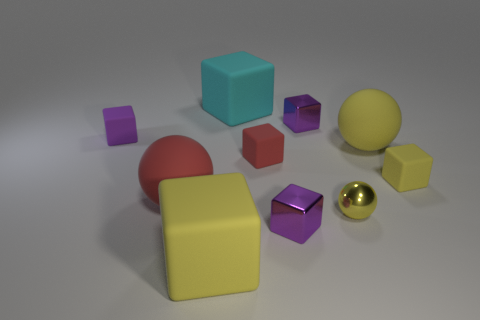How many other things are there of the same size as the yellow matte sphere?
Your response must be concise. 3. What material is the purple object in front of the large object on the right side of the purple thing that is in front of the tiny red matte block?
Offer a terse response. Metal. Is the material of the small red cube the same as the yellow thing that is left of the tiny yellow sphere?
Your answer should be very brief. Yes. Is the number of large yellow rubber spheres that are left of the big yellow rubber block less than the number of red rubber objects that are in front of the tiny red cube?
Give a very brief answer. Yes. What number of tiny red blocks are the same material as the red sphere?
Keep it short and to the point. 1. There is a large cube that is on the right side of the large yellow rubber thing left of the red matte block; are there any tiny rubber objects that are in front of it?
Provide a short and direct response. Yes. What number of blocks are tiny red matte things or big yellow matte things?
Give a very brief answer. 2. There is a tiny red thing; does it have the same shape as the small purple metal object in front of the red sphere?
Provide a succinct answer. Yes. Are there fewer metal things that are to the right of the yellow shiny sphere than tiny yellow rubber objects?
Your answer should be compact. Yes. Are there any small matte blocks in front of the small purple rubber thing?
Your response must be concise. Yes. 